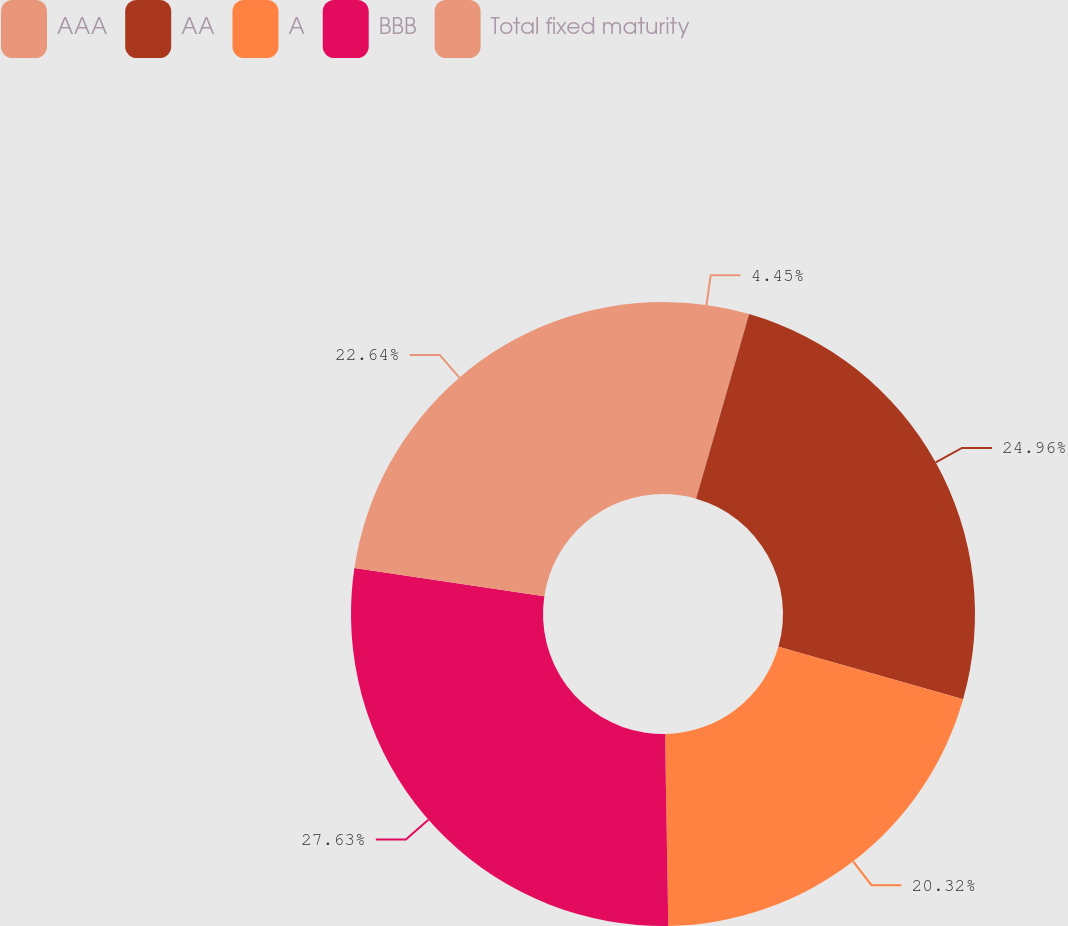<chart> <loc_0><loc_0><loc_500><loc_500><pie_chart><fcel>AAA<fcel>AA<fcel>A<fcel>BBB<fcel>Total fixed maturity<nl><fcel>4.45%<fcel>24.96%<fcel>20.32%<fcel>27.63%<fcel>22.64%<nl></chart> 